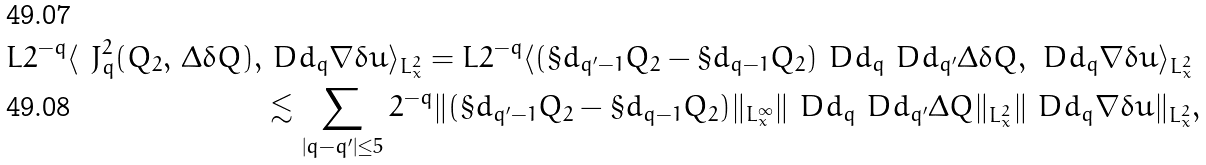<formula> <loc_0><loc_0><loc_500><loc_500>L 2 ^ { - q } \langle \ J _ { q } ^ { 2 } ( Q _ { 2 } , \, \Delta \delta Q ) , & \ D d _ { q } \nabla \delta u \rangle _ { L ^ { 2 } _ { x } } = L 2 ^ { - q } \langle ( \S d _ { q ^ { \prime } - 1 } Q _ { 2 } - \S d _ { q - 1 } Q _ { 2 } ) \ D d _ { q } \ D d _ { q ^ { \prime } } \Delta \delta Q , \ D d _ { q } \nabla \delta u \rangle _ { L ^ { 2 } _ { x } } \\ & \lesssim \sum _ { | q - q ^ { \prime } | \leq 5 } 2 ^ { - q } \| ( \S d _ { q ^ { \prime } - 1 } Q _ { 2 } - \S d _ { q - 1 } Q _ { 2 } ) \| _ { L ^ { \infty } _ { x } } \| \ D d _ { q } \ D d _ { q ^ { \prime } } \Delta Q \| _ { L ^ { 2 } _ { x } } \| \ D d _ { q } \nabla \delta u \| _ { L ^ { 2 } _ { x } } ,</formula> 